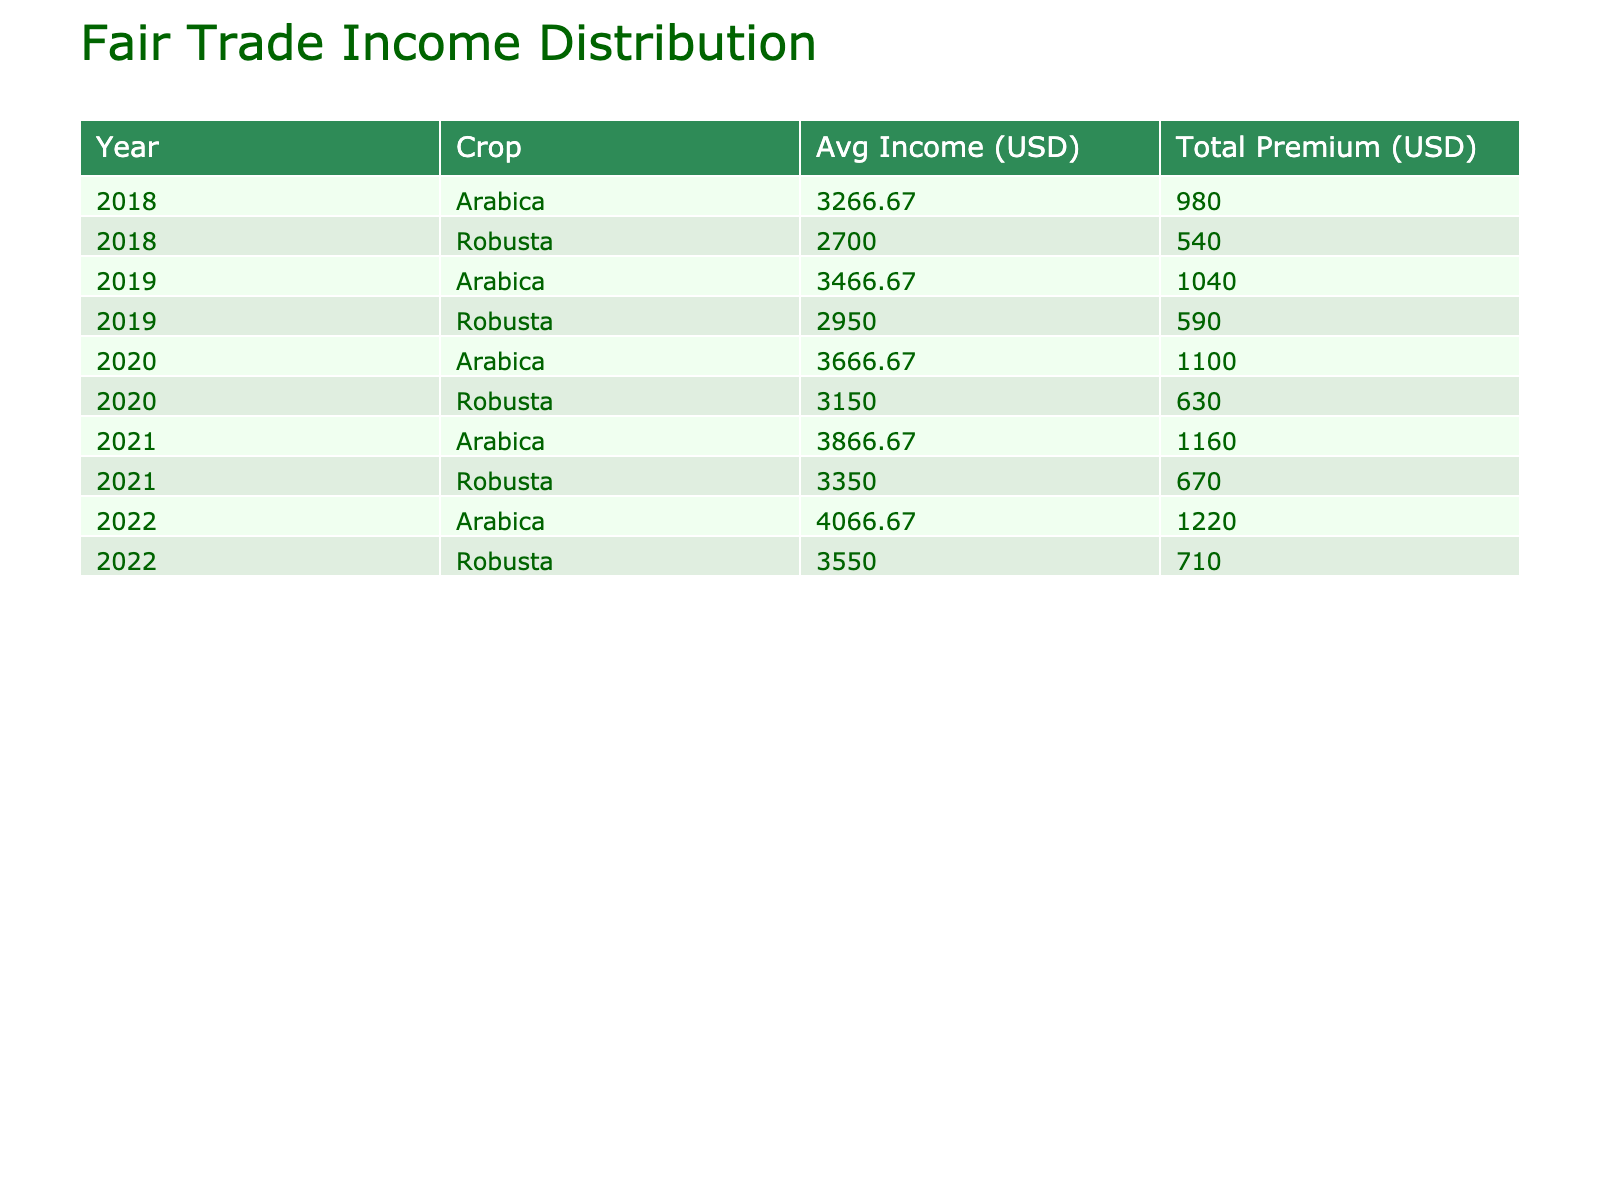What was the average income from Arabica crops in 2020? The average income from Arabica crops can be found by looking at the Income values for Arabica in 2020, which are for Maria Rodriguez (3600), Ana Martinez (3900), and Isabel Torres (3500). Adding these gives us a total of 3600 + 3900 + 3500 = 11000. Since there are 3 farmers, we divide this total by 3 to find the average: 11000 / 3 = 3666.67.
Answer: 3666.67 Which crop generated the highest total fair trade premium in 2021? To find which crop generated the highest total fair trade premium in 2021, we look at the Fair Trade Premium for each crop in that year: for Arabica, the premiums are 380 (Maria), 410 (Ana), and 370 (Isabel), totaling 1160. For Robusta, the premiums are 340 (Juan) and 330 (Carlos), totaling 670. Comparing these totals, Arabica (1160) is higher than Robusta (670).
Answer: Arabica How much did Carlos Sanchez earn from Robusta over the five years combined? To calculate Carlos Sanchez's total income from Robusta from 2018 to 2022, we extract the income values for each year: 2600 (2018), 2900 (2019), 3100 (2020), 3300 (2021), and 3500 (2022). Adding these values gives us: 2600 + 2900 + 3100 + 3300 + 3500 = 15400. Therefore, Carlos Sanchez earned a total of 15400 from Robusta over five years.
Answer: 15400 Did Ana Martinez receive a fair trade premium higher than 400 in any year? Checking Ana Martinez's fair trade premiums year by year: in 2018, she received 350; in 2019, she received 370; in 2020, she received 390; in 2021, she received 410; and in 2022, she received 430. Since she received 410 and 430 in 2021 and 2022 respectively, these are both higher than 400. Thus, the answer is yes.
Answer: Yes What is the trend of average income for Arabica crops from 2018 to 2022? To analyze the trend, we look at the average income for Arabica per year: 3200 (2018), 3400 (2019), 3600 (2020), 3800 (2021), and 4000 (2022). Observing these figures, we see a consistent increase each year: 3200 to 3400 (+200), 3400 to 3600 (+200), 3600 to 3800 (+200), and 3800 to 4000 (+200). This indicates that the average income for Arabica crops has steadily increased over the five years.
Answer: Increasing 